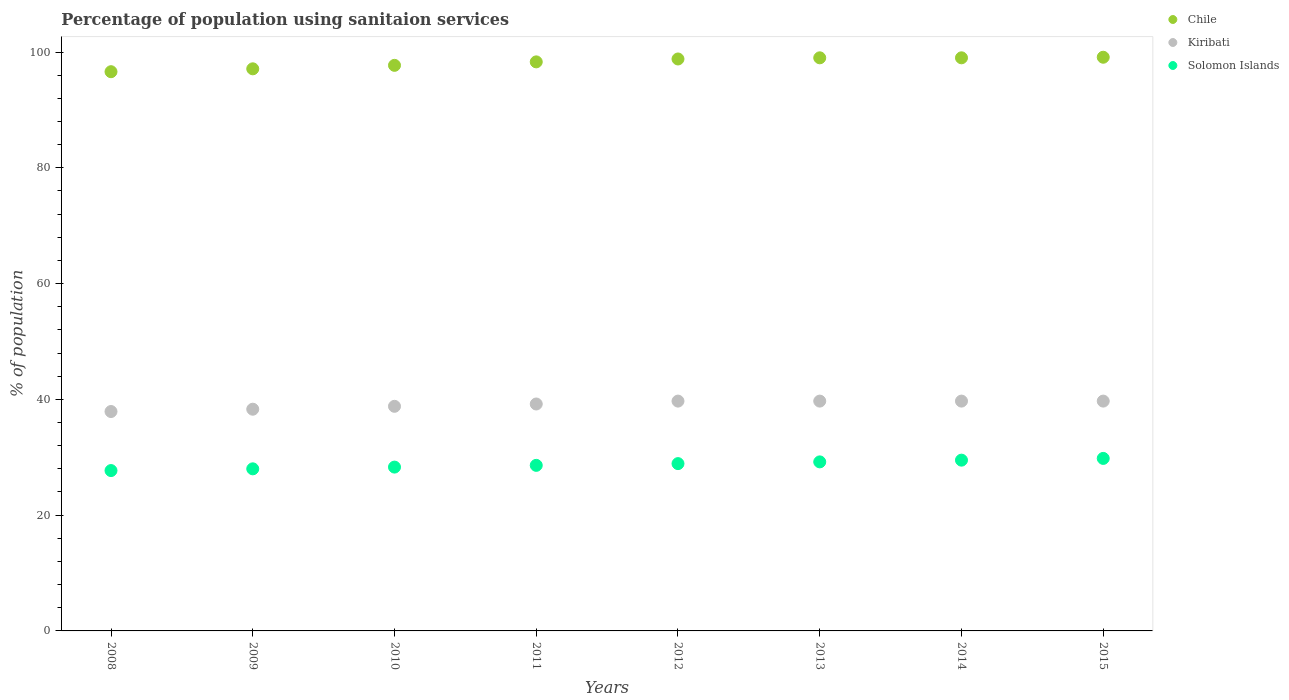Is the number of dotlines equal to the number of legend labels?
Give a very brief answer. Yes. What is the percentage of population using sanitaion services in Chile in 2013?
Give a very brief answer. 99. Across all years, what is the maximum percentage of population using sanitaion services in Chile?
Offer a very short reply. 99.1. Across all years, what is the minimum percentage of population using sanitaion services in Kiribati?
Offer a terse response. 37.9. What is the total percentage of population using sanitaion services in Solomon Islands in the graph?
Your answer should be very brief. 230. What is the difference between the percentage of population using sanitaion services in Solomon Islands in 2011 and that in 2014?
Your answer should be very brief. -0.9. What is the difference between the percentage of population using sanitaion services in Chile in 2015 and the percentage of population using sanitaion services in Solomon Islands in 2012?
Offer a very short reply. 70.2. What is the average percentage of population using sanitaion services in Chile per year?
Offer a very short reply. 98.2. In the year 2008, what is the difference between the percentage of population using sanitaion services in Chile and percentage of population using sanitaion services in Solomon Islands?
Offer a very short reply. 68.9. In how many years, is the percentage of population using sanitaion services in Solomon Islands greater than 88 %?
Your answer should be very brief. 0. What is the ratio of the percentage of population using sanitaion services in Chile in 2008 to that in 2011?
Your response must be concise. 0.98. What is the difference between the highest and the second highest percentage of population using sanitaion services in Chile?
Your answer should be compact. 0.1. What is the difference between the highest and the lowest percentage of population using sanitaion services in Kiribati?
Keep it short and to the point. 1.8. Is the sum of the percentage of population using sanitaion services in Chile in 2012 and 2015 greater than the maximum percentage of population using sanitaion services in Kiribati across all years?
Provide a succinct answer. Yes. Does the percentage of population using sanitaion services in Solomon Islands monotonically increase over the years?
Provide a short and direct response. Yes. How many dotlines are there?
Provide a succinct answer. 3. Are the values on the major ticks of Y-axis written in scientific E-notation?
Provide a succinct answer. No. Does the graph contain any zero values?
Provide a short and direct response. No. How many legend labels are there?
Your answer should be compact. 3. What is the title of the graph?
Offer a very short reply. Percentage of population using sanitaion services. Does "Madagascar" appear as one of the legend labels in the graph?
Keep it short and to the point. No. What is the label or title of the X-axis?
Your answer should be very brief. Years. What is the label or title of the Y-axis?
Make the answer very short. % of population. What is the % of population in Chile in 2008?
Keep it short and to the point. 96.6. What is the % of population in Kiribati in 2008?
Keep it short and to the point. 37.9. What is the % of population of Solomon Islands in 2008?
Provide a succinct answer. 27.7. What is the % of population in Chile in 2009?
Offer a terse response. 97.1. What is the % of population in Kiribati in 2009?
Make the answer very short. 38.3. What is the % of population in Chile in 2010?
Provide a succinct answer. 97.7. What is the % of population of Kiribati in 2010?
Offer a terse response. 38.8. What is the % of population in Solomon Islands in 2010?
Ensure brevity in your answer.  28.3. What is the % of population of Chile in 2011?
Keep it short and to the point. 98.3. What is the % of population of Kiribati in 2011?
Provide a succinct answer. 39.2. What is the % of population of Solomon Islands in 2011?
Make the answer very short. 28.6. What is the % of population of Chile in 2012?
Provide a short and direct response. 98.8. What is the % of population of Kiribati in 2012?
Your response must be concise. 39.7. What is the % of population of Solomon Islands in 2012?
Make the answer very short. 28.9. What is the % of population of Kiribati in 2013?
Make the answer very short. 39.7. What is the % of population of Solomon Islands in 2013?
Offer a very short reply. 29.2. What is the % of population in Kiribati in 2014?
Ensure brevity in your answer.  39.7. What is the % of population in Solomon Islands in 2014?
Offer a terse response. 29.5. What is the % of population of Chile in 2015?
Your answer should be compact. 99.1. What is the % of population in Kiribati in 2015?
Offer a very short reply. 39.7. What is the % of population in Solomon Islands in 2015?
Provide a succinct answer. 29.8. Across all years, what is the maximum % of population of Chile?
Your answer should be very brief. 99.1. Across all years, what is the maximum % of population in Kiribati?
Your answer should be compact. 39.7. Across all years, what is the maximum % of population in Solomon Islands?
Provide a short and direct response. 29.8. Across all years, what is the minimum % of population in Chile?
Your answer should be very brief. 96.6. Across all years, what is the minimum % of population in Kiribati?
Your response must be concise. 37.9. Across all years, what is the minimum % of population of Solomon Islands?
Keep it short and to the point. 27.7. What is the total % of population of Chile in the graph?
Your answer should be very brief. 785.6. What is the total % of population in Kiribati in the graph?
Your answer should be very brief. 313. What is the total % of population in Solomon Islands in the graph?
Offer a terse response. 230. What is the difference between the % of population in Solomon Islands in 2008 and that in 2009?
Ensure brevity in your answer.  -0.3. What is the difference between the % of population in Kiribati in 2008 and that in 2010?
Keep it short and to the point. -0.9. What is the difference between the % of population in Solomon Islands in 2008 and that in 2010?
Provide a short and direct response. -0.6. What is the difference between the % of population in Chile in 2008 and that in 2012?
Ensure brevity in your answer.  -2.2. What is the difference between the % of population in Solomon Islands in 2008 and that in 2012?
Your answer should be very brief. -1.2. What is the difference between the % of population of Chile in 2008 and that in 2013?
Your answer should be very brief. -2.4. What is the difference between the % of population of Kiribati in 2008 and that in 2013?
Give a very brief answer. -1.8. What is the difference between the % of population of Solomon Islands in 2008 and that in 2013?
Your response must be concise. -1.5. What is the difference between the % of population in Chile in 2008 and that in 2014?
Offer a very short reply. -2.4. What is the difference between the % of population in Kiribati in 2008 and that in 2015?
Make the answer very short. -1.8. What is the difference between the % of population of Chile in 2009 and that in 2010?
Ensure brevity in your answer.  -0.6. What is the difference between the % of population in Chile in 2009 and that in 2011?
Provide a short and direct response. -1.2. What is the difference between the % of population of Kiribati in 2009 and that in 2011?
Make the answer very short. -0.9. What is the difference between the % of population of Chile in 2009 and that in 2012?
Provide a succinct answer. -1.7. What is the difference between the % of population in Chile in 2009 and that in 2013?
Ensure brevity in your answer.  -1.9. What is the difference between the % of population of Chile in 2009 and that in 2014?
Provide a short and direct response. -1.9. What is the difference between the % of population in Kiribati in 2009 and that in 2014?
Give a very brief answer. -1.4. What is the difference between the % of population of Solomon Islands in 2009 and that in 2014?
Keep it short and to the point. -1.5. What is the difference between the % of population in Chile in 2009 and that in 2015?
Your answer should be compact. -2. What is the difference between the % of population in Kiribati in 2009 and that in 2015?
Your response must be concise. -1.4. What is the difference between the % of population of Chile in 2010 and that in 2011?
Ensure brevity in your answer.  -0.6. What is the difference between the % of population of Solomon Islands in 2010 and that in 2011?
Ensure brevity in your answer.  -0.3. What is the difference between the % of population of Chile in 2010 and that in 2012?
Your answer should be compact. -1.1. What is the difference between the % of population in Kiribati in 2010 and that in 2012?
Give a very brief answer. -0.9. What is the difference between the % of population in Solomon Islands in 2010 and that in 2012?
Provide a short and direct response. -0.6. What is the difference between the % of population in Kiribati in 2010 and that in 2013?
Offer a terse response. -0.9. What is the difference between the % of population in Solomon Islands in 2010 and that in 2014?
Offer a terse response. -1.2. What is the difference between the % of population in Chile in 2010 and that in 2015?
Your answer should be compact. -1.4. What is the difference between the % of population in Solomon Islands in 2010 and that in 2015?
Offer a terse response. -1.5. What is the difference between the % of population of Solomon Islands in 2011 and that in 2012?
Keep it short and to the point. -0.3. What is the difference between the % of population in Kiribati in 2011 and that in 2013?
Offer a terse response. -0.5. What is the difference between the % of population in Solomon Islands in 2011 and that in 2013?
Ensure brevity in your answer.  -0.6. What is the difference between the % of population of Solomon Islands in 2011 and that in 2014?
Give a very brief answer. -0.9. What is the difference between the % of population of Kiribati in 2011 and that in 2015?
Offer a terse response. -0.5. What is the difference between the % of population of Solomon Islands in 2011 and that in 2015?
Ensure brevity in your answer.  -1.2. What is the difference between the % of population in Chile in 2012 and that in 2013?
Ensure brevity in your answer.  -0.2. What is the difference between the % of population in Kiribati in 2012 and that in 2014?
Your response must be concise. 0. What is the difference between the % of population in Solomon Islands in 2012 and that in 2014?
Provide a short and direct response. -0.6. What is the difference between the % of population in Chile in 2013 and that in 2014?
Offer a terse response. 0. What is the difference between the % of population of Solomon Islands in 2013 and that in 2015?
Make the answer very short. -0.6. What is the difference between the % of population in Solomon Islands in 2014 and that in 2015?
Give a very brief answer. -0.3. What is the difference between the % of population of Chile in 2008 and the % of population of Kiribati in 2009?
Your response must be concise. 58.3. What is the difference between the % of population of Chile in 2008 and the % of population of Solomon Islands in 2009?
Offer a terse response. 68.6. What is the difference between the % of population in Kiribati in 2008 and the % of population in Solomon Islands in 2009?
Provide a short and direct response. 9.9. What is the difference between the % of population of Chile in 2008 and the % of population of Kiribati in 2010?
Give a very brief answer. 57.8. What is the difference between the % of population of Chile in 2008 and the % of population of Solomon Islands in 2010?
Offer a terse response. 68.3. What is the difference between the % of population of Kiribati in 2008 and the % of population of Solomon Islands in 2010?
Give a very brief answer. 9.6. What is the difference between the % of population in Chile in 2008 and the % of population in Kiribati in 2011?
Give a very brief answer. 57.4. What is the difference between the % of population of Kiribati in 2008 and the % of population of Solomon Islands in 2011?
Give a very brief answer. 9.3. What is the difference between the % of population in Chile in 2008 and the % of population in Kiribati in 2012?
Provide a succinct answer. 56.9. What is the difference between the % of population in Chile in 2008 and the % of population in Solomon Islands in 2012?
Keep it short and to the point. 67.7. What is the difference between the % of population in Kiribati in 2008 and the % of population in Solomon Islands in 2012?
Your answer should be compact. 9. What is the difference between the % of population in Chile in 2008 and the % of population in Kiribati in 2013?
Offer a very short reply. 56.9. What is the difference between the % of population in Chile in 2008 and the % of population in Solomon Islands in 2013?
Provide a short and direct response. 67.4. What is the difference between the % of population of Chile in 2008 and the % of population of Kiribati in 2014?
Keep it short and to the point. 56.9. What is the difference between the % of population in Chile in 2008 and the % of population in Solomon Islands in 2014?
Provide a short and direct response. 67.1. What is the difference between the % of population in Kiribati in 2008 and the % of population in Solomon Islands in 2014?
Offer a very short reply. 8.4. What is the difference between the % of population in Chile in 2008 and the % of population in Kiribati in 2015?
Give a very brief answer. 56.9. What is the difference between the % of population of Chile in 2008 and the % of population of Solomon Islands in 2015?
Make the answer very short. 66.8. What is the difference between the % of population of Kiribati in 2008 and the % of population of Solomon Islands in 2015?
Keep it short and to the point. 8.1. What is the difference between the % of population in Chile in 2009 and the % of population in Kiribati in 2010?
Keep it short and to the point. 58.3. What is the difference between the % of population in Chile in 2009 and the % of population in Solomon Islands in 2010?
Offer a terse response. 68.8. What is the difference between the % of population in Kiribati in 2009 and the % of population in Solomon Islands in 2010?
Ensure brevity in your answer.  10. What is the difference between the % of population of Chile in 2009 and the % of population of Kiribati in 2011?
Keep it short and to the point. 57.9. What is the difference between the % of population in Chile in 2009 and the % of population in Solomon Islands in 2011?
Offer a terse response. 68.5. What is the difference between the % of population of Chile in 2009 and the % of population of Kiribati in 2012?
Provide a succinct answer. 57.4. What is the difference between the % of population in Chile in 2009 and the % of population in Solomon Islands in 2012?
Give a very brief answer. 68.2. What is the difference between the % of population in Kiribati in 2009 and the % of population in Solomon Islands in 2012?
Keep it short and to the point. 9.4. What is the difference between the % of population in Chile in 2009 and the % of population in Kiribati in 2013?
Keep it short and to the point. 57.4. What is the difference between the % of population in Chile in 2009 and the % of population in Solomon Islands in 2013?
Provide a succinct answer. 67.9. What is the difference between the % of population in Kiribati in 2009 and the % of population in Solomon Islands in 2013?
Your answer should be compact. 9.1. What is the difference between the % of population of Chile in 2009 and the % of population of Kiribati in 2014?
Provide a succinct answer. 57.4. What is the difference between the % of population of Chile in 2009 and the % of population of Solomon Islands in 2014?
Your answer should be compact. 67.6. What is the difference between the % of population of Kiribati in 2009 and the % of population of Solomon Islands in 2014?
Provide a succinct answer. 8.8. What is the difference between the % of population of Chile in 2009 and the % of population of Kiribati in 2015?
Offer a terse response. 57.4. What is the difference between the % of population in Chile in 2009 and the % of population in Solomon Islands in 2015?
Keep it short and to the point. 67.3. What is the difference between the % of population in Kiribati in 2009 and the % of population in Solomon Islands in 2015?
Your response must be concise. 8.5. What is the difference between the % of population of Chile in 2010 and the % of population of Kiribati in 2011?
Offer a terse response. 58.5. What is the difference between the % of population in Chile in 2010 and the % of population in Solomon Islands in 2011?
Give a very brief answer. 69.1. What is the difference between the % of population in Kiribati in 2010 and the % of population in Solomon Islands in 2011?
Make the answer very short. 10.2. What is the difference between the % of population of Chile in 2010 and the % of population of Kiribati in 2012?
Ensure brevity in your answer.  58. What is the difference between the % of population in Chile in 2010 and the % of population in Solomon Islands in 2012?
Your response must be concise. 68.8. What is the difference between the % of population of Chile in 2010 and the % of population of Kiribati in 2013?
Provide a succinct answer. 58. What is the difference between the % of population in Chile in 2010 and the % of population in Solomon Islands in 2013?
Your answer should be very brief. 68.5. What is the difference between the % of population of Kiribati in 2010 and the % of population of Solomon Islands in 2013?
Ensure brevity in your answer.  9.6. What is the difference between the % of population in Chile in 2010 and the % of population in Kiribati in 2014?
Make the answer very short. 58. What is the difference between the % of population of Chile in 2010 and the % of population of Solomon Islands in 2014?
Give a very brief answer. 68.2. What is the difference between the % of population of Kiribati in 2010 and the % of population of Solomon Islands in 2014?
Your answer should be compact. 9.3. What is the difference between the % of population of Chile in 2010 and the % of population of Solomon Islands in 2015?
Offer a terse response. 67.9. What is the difference between the % of population of Chile in 2011 and the % of population of Kiribati in 2012?
Provide a short and direct response. 58.6. What is the difference between the % of population of Chile in 2011 and the % of population of Solomon Islands in 2012?
Provide a short and direct response. 69.4. What is the difference between the % of population of Chile in 2011 and the % of population of Kiribati in 2013?
Your response must be concise. 58.6. What is the difference between the % of population of Chile in 2011 and the % of population of Solomon Islands in 2013?
Ensure brevity in your answer.  69.1. What is the difference between the % of population in Kiribati in 2011 and the % of population in Solomon Islands in 2013?
Your answer should be very brief. 10. What is the difference between the % of population in Chile in 2011 and the % of population in Kiribati in 2014?
Make the answer very short. 58.6. What is the difference between the % of population in Chile in 2011 and the % of population in Solomon Islands in 2014?
Your answer should be compact. 68.8. What is the difference between the % of population in Chile in 2011 and the % of population in Kiribati in 2015?
Your answer should be compact. 58.6. What is the difference between the % of population in Chile in 2011 and the % of population in Solomon Islands in 2015?
Your answer should be very brief. 68.5. What is the difference between the % of population in Chile in 2012 and the % of population in Kiribati in 2013?
Your answer should be compact. 59.1. What is the difference between the % of population in Chile in 2012 and the % of population in Solomon Islands in 2013?
Give a very brief answer. 69.6. What is the difference between the % of population in Chile in 2012 and the % of population in Kiribati in 2014?
Offer a very short reply. 59.1. What is the difference between the % of population of Chile in 2012 and the % of population of Solomon Islands in 2014?
Offer a very short reply. 69.3. What is the difference between the % of population in Chile in 2012 and the % of population in Kiribati in 2015?
Keep it short and to the point. 59.1. What is the difference between the % of population in Kiribati in 2012 and the % of population in Solomon Islands in 2015?
Your answer should be compact. 9.9. What is the difference between the % of population in Chile in 2013 and the % of population in Kiribati in 2014?
Offer a very short reply. 59.3. What is the difference between the % of population in Chile in 2013 and the % of population in Solomon Islands in 2014?
Your answer should be very brief. 69.5. What is the difference between the % of population of Kiribati in 2013 and the % of population of Solomon Islands in 2014?
Your response must be concise. 10.2. What is the difference between the % of population in Chile in 2013 and the % of population in Kiribati in 2015?
Ensure brevity in your answer.  59.3. What is the difference between the % of population of Chile in 2013 and the % of population of Solomon Islands in 2015?
Make the answer very short. 69.2. What is the difference between the % of population of Kiribati in 2013 and the % of population of Solomon Islands in 2015?
Ensure brevity in your answer.  9.9. What is the difference between the % of population of Chile in 2014 and the % of population of Kiribati in 2015?
Ensure brevity in your answer.  59.3. What is the difference between the % of population of Chile in 2014 and the % of population of Solomon Islands in 2015?
Ensure brevity in your answer.  69.2. What is the difference between the % of population in Kiribati in 2014 and the % of population in Solomon Islands in 2015?
Offer a terse response. 9.9. What is the average % of population of Chile per year?
Offer a terse response. 98.2. What is the average % of population in Kiribati per year?
Keep it short and to the point. 39.12. What is the average % of population in Solomon Islands per year?
Keep it short and to the point. 28.75. In the year 2008, what is the difference between the % of population of Chile and % of population of Kiribati?
Provide a succinct answer. 58.7. In the year 2008, what is the difference between the % of population of Chile and % of population of Solomon Islands?
Give a very brief answer. 68.9. In the year 2008, what is the difference between the % of population of Kiribati and % of population of Solomon Islands?
Your answer should be compact. 10.2. In the year 2009, what is the difference between the % of population in Chile and % of population in Kiribati?
Ensure brevity in your answer.  58.8. In the year 2009, what is the difference between the % of population in Chile and % of population in Solomon Islands?
Offer a very short reply. 69.1. In the year 2009, what is the difference between the % of population in Kiribati and % of population in Solomon Islands?
Your answer should be compact. 10.3. In the year 2010, what is the difference between the % of population in Chile and % of population in Kiribati?
Make the answer very short. 58.9. In the year 2010, what is the difference between the % of population in Chile and % of population in Solomon Islands?
Provide a succinct answer. 69.4. In the year 2011, what is the difference between the % of population in Chile and % of population in Kiribati?
Make the answer very short. 59.1. In the year 2011, what is the difference between the % of population of Chile and % of population of Solomon Islands?
Give a very brief answer. 69.7. In the year 2012, what is the difference between the % of population in Chile and % of population in Kiribati?
Keep it short and to the point. 59.1. In the year 2012, what is the difference between the % of population of Chile and % of population of Solomon Islands?
Your answer should be very brief. 69.9. In the year 2012, what is the difference between the % of population of Kiribati and % of population of Solomon Islands?
Offer a terse response. 10.8. In the year 2013, what is the difference between the % of population of Chile and % of population of Kiribati?
Offer a very short reply. 59.3. In the year 2013, what is the difference between the % of population of Chile and % of population of Solomon Islands?
Give a very brief answer. 69.8. In the year 2014, what is the difference between the % of population in Chile and % of population in Kiribati?
Provide a short and direct response. 59.3. In the year 2014, what is the difference between the % of population of Chile and % of population of Solomon Islands?
Provide a short and direct response. 69.5. In the year 2014, what is the difference between the % of population in Kiribati and % of population in Solomon Islands?
Provide a succinct answer. 10.2. In the year 2015, what is the difference between the % of population in Chile and % of population in Kiribati?
Keep it short and to the point. 59.4. In the year 2015, what is the difference between the % of population of Chile and % of population of Solomon Islands?
Your response must be concise. 69.3. In the year 2015, what is the difference between the % of population of Kiribati and % of population of Solomon Islands?
Offer a terse response. 9.9. What is the ratio of the % of population in Solomon Islands in 2008 to that in 2009?
Make the answer very short. 0.99. What is the ratio of the % of population in Chile in 2008 to that in 2010?
Offer a terse response. 0.99. What is the ratio of the % of population in Kiribati in 2008 to that in 2010?
Your answer should be compact. 0.98. What is the ratio of the % of population in Solomon Islands in 2008 to that in 2010?
Provide a succinct answer. 0.98. What is the ratio of the % of population of Chile in 2008 to that in 2011?
Offer a terse response. 0.98. What is the ratio of the % of population in Kiribati in 2008 to that in 2011?
Your response must be concise. 0.97. What is the ratio of the % of population in Solomon Islands in 2008 to that in 2011?
Give a very brief answer. 0.97. What is the ratio of the % of population in Chile in 2008 to that in 2012?
Make the answer very short. 0.98. What is the ratio of the % of population in Kiribati in 2008 to that in 2012?
Give a very brief answer. 0.95. What is the ratio of the % of population of Solomon Islands in 2008 to that in 2012?
Provide a succinct answer. 0.96. What is the ratio of the % of population in Chile in 2008 to that in 2013?
Provide a short and direct response. 0.98. What is the ratio of the % of population in Kiribati in 2008 to that in 2013?
Your answer should be very brief. 0.95. What is the ratio of the % of population of Solomon Islands in 2008 to that in 2013?
Provide a short and direct response. 0.95. What is the ratio of the % of population of Chile in 2008 to that in 2014?
Your response must be concise. 0.98. What is the ratio of the % of population of Kiribati in 2008 to that in 2014?
Provide a short and direct response. 0.95. What is the ratio of the % of population of Solomon Islands in 2008 to that in 2014?
Make the answer very short. 0.94. What is the ratio of the % of population in Chile in 2008 to that in 2015?
Make the answer very short. 0.97. What is the ratio of the % of population of Kiribati in 2008 to that in 2015?
Provide a succinct answer. 0.95. What is the ratio of the % of population of Solomon Islands in 2008 to that in 2015?
Provide a short and direct response. 0.93. What is the ratio of the % of population of Kiribati in 2009 to that in 2010?
Keep it short and to the point. 0.99. What is the ratio of the % of population of Solomon Islands in 2009 to that in 2010?
Your answer should be very brief. 0.99. What is the ratio of the % of population in Chile in 2009 to that in 2011?
Your response must be concise. 0.99. What is the ratio of the % of population of Solomon Islands in 2009 to that in 2011?
Make the answer very short. 0.98. What is the ratio of the % of population in Chile in 2009 to that in 2012?
Make the answer very short. 0.98. What is the ratio of the % of population of Kiribati in 2009 to that in 2012?
Give a very brief answer. 0.96. What is the ratio of the % of population of Solomon Islands in 2009 to that in 2012?
Provide a short and direct response. 0.97. What is the ratio of the % of population in Chile in 2009 to that in 2013?
Offer a very short reply. 0.98. What is the ratio of the % of population in Kiribati in 2009 to that in 2013?
Offer a very short reply. 0.96. What is the ratio of the % of population of Solomon Islands in 2009 to that in 2013?
Your response must be concise. 0.96. What is the ratio of the % of population of Chile in 2009 to that in 2014?
Your response must be concise. 0.98. What is the ratio of the % of population of Kiribati in 2009 to that in 2014?
Keep it short and to the point. 0.96. What is the ratio of the % of population in Solomon Islands in 2009 to that in 2014?
Offer a terse response. 0.95. What is the ratio of the % of population in Chile in 2009 to that in 2015?
Provide a succinct answer. 0.98. What is the ratio of the % of population of Kiribati in 2009 to that in 2015?
Your answer should be very brief. 0.96. What is the ratio of the % of population in Solomon Islands in 2009 to that in 2015?
Your response must be concise. 0.94. What is the ratio of the % of population of Chile in 2010 to that in 2011?
Give a very brief answer. 0.99. What is the ratio of the % of population of Kiribati in 2010 to that in 2011?
Your answer should be compact. 0.99. What is the ratio of the % of population in Solomon Islands in 2010 to that in 2011?
Provide a succinct answer. 0.99. What is the ratio of the % of population in Chile in 2010 to that in 2012?
Your answer should be very brief. 0.99. What is the ratio of the % of population of Kiribati in 2010 to that in 2012?
Give a very brief answer. 0.98. What is the ratio of the % of population of Solomon Islands in 2010 to that in 2012?
Offer a very short reply. 0.98. What is the ratio of the % of population of Chile in 2010 to that in 2013?
Provide a succinct answer. 0.99. What is the ratio of the % of population of Kiribati in 2010 to that in 2013?
Give a very brief answer. 0.98. What is the ratio of the % of population in Solomon Islands in 2010 to that in 2013?
Keep it short and to the point. 0.97. What is the ratio of the % of population of Chile in 2010 to that in 2014?
Offer a very short reply. 0.99. What is the ratio of the % of population of Kiribati in 2010 to that in 2014?
Ensure brevity in your answer.  0.98. What is the ratio of the % of population of Solomon Islands in 2010 to that in 2014?
Ensure brevity in your answer.  0.96. What is the ratio of the % of population in Chile in 2010 to that in 2015?
Offer a very short reply. 0.99. What is the ratio of the % of population in Kiribati in 2010 to that in 2015?
Your answer should be compact. 0.98. What is the ratio of the % of population of Solomon Islands in 2010 to that in 2015?
Offer a terse response. 0.95. What is the ratio of the % of population in Kiribati in 2011 to that in 2012?
Offer a very short reply. 0.99. What is the ratio of the % of population of Chile in 2011 to that in 2013?
Offer a very short reply. 0.99. What is the ratio of the % of population in Kiribati in 2011 to that in 2013?
Offer a terse response. 0.99. What is the ratio of the % of population in Solomon Islands in 2011 to that in 2013?
Provide a short and direct response. 0.98. What is the ratio of the % of population of Kiribati in 2011 to that in 2014?
Provide a short and direct response. 0.99. What is the ratio of the % of population of Solomon Islands in 2011 to that in 2014?
Give a very brief answer. 0.97. What is the ratio of the % of population in Kiribati in 2011 to that in 2015?
Offer a terse response. 0.99. What is the ratio of the % of population of Solomon Islands in 2011 to that in 2015?
Offer a terse response. 0.96. What is the ratio of the % of population of Solomon Islands in 2012 to that in 2013?
Make the answer very short. 0.99. What is the ratio of the % of population of Solomon Islands in 2012 to that in 2014?
Give a very brief answer. 0.98. What is the ratio of the % of population of Chile in 2012 to that in 2015?
Keep it short and to the point. 1. What is the ratio of the % of population of Kiribati in 2012 to that in 2015?
Your answer should be compact. 1. What is the ratio of the % of population of Solomon Islands in 2012 to that in 2015?
Your answer should be very brief. 0.97. What is the ratio of the % of population of Chile in 2013 to that in 2015?
Give a very brief answer. 1. What is the ratio of the % of population in Kiribati in 2013 to that in 2015?
Offer a very short reply. 1. What is the ratio of the % of population of Solomon Islands in 2013 to that in 2015?
Your answer should be compact. 0.98. What is the ratio of the % of population of Kiribati in 2014 to that in 2015?
Your answer should be very brief. 1. What is the ratio of the % of population of Solomon Islands in 2014 to that in 2015?
Your answer should be compact. 0.99. What is the difference between the highest and the second highest % of population of Kiribati?
Your answer should be compact. 0. What is the difference between the highest and the lowest % of population of Kiribati?
Your answer should be compact. 1.8. What is the difference between the highest and the lowest % of population in Solomon Islands?
Keep it short and to the point. 2.1. 